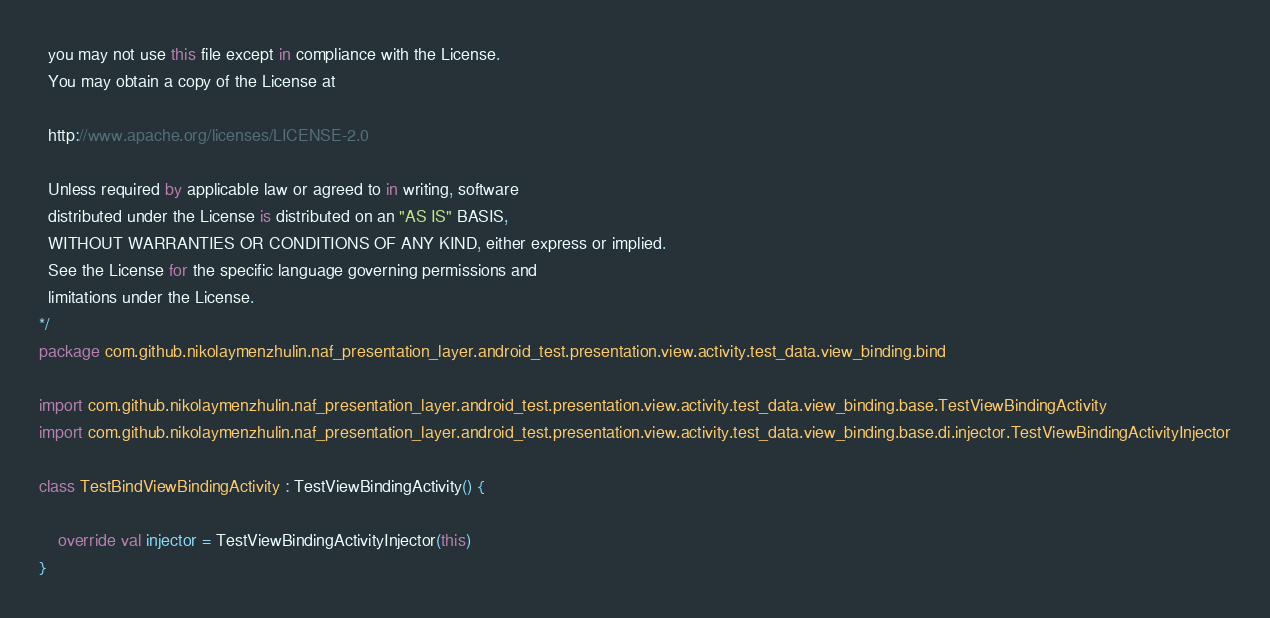<code> <loc_0><loc_0><loc_500><loc_500><_Kotlin_>  you may not use this file except in compliance with the License.
  You may obtain a copy of the License at

  http://www.apache.org/licenses/LICENSE-2.0

  Unless required by applicable law or agreed to in writing, software
  distributed under the License is distributed on an "AS IS" BASIS,
  WITHOUT WARRANTIES OR CONDITIONS OF ANY KIND, either express or implied.
  See the License for the specific language governing permissions and
  limitations under the License.
*/
package com.github.nikolaymenzhulin.naf_presentation_layer.android_test.presentation.view.activity.test_data.view_binding.bind

import com.github.nikolaymenzhulin.naf_presentation_layer.android_test.presentation.view.activity.test_data.view_binding.base.TestViewBindingActivity
import com.github.nikolaymenzhulin.naf_presentation_layer.android_test.presentation.view.activity.test_data.view_binding.base.di.injector.TestViewBindingActivityInjector

class TestBindViewBindingActivity : TestViewBindingActivity() {

    override val injector = TestViewBindingActivityInjector(this)
}</code> 